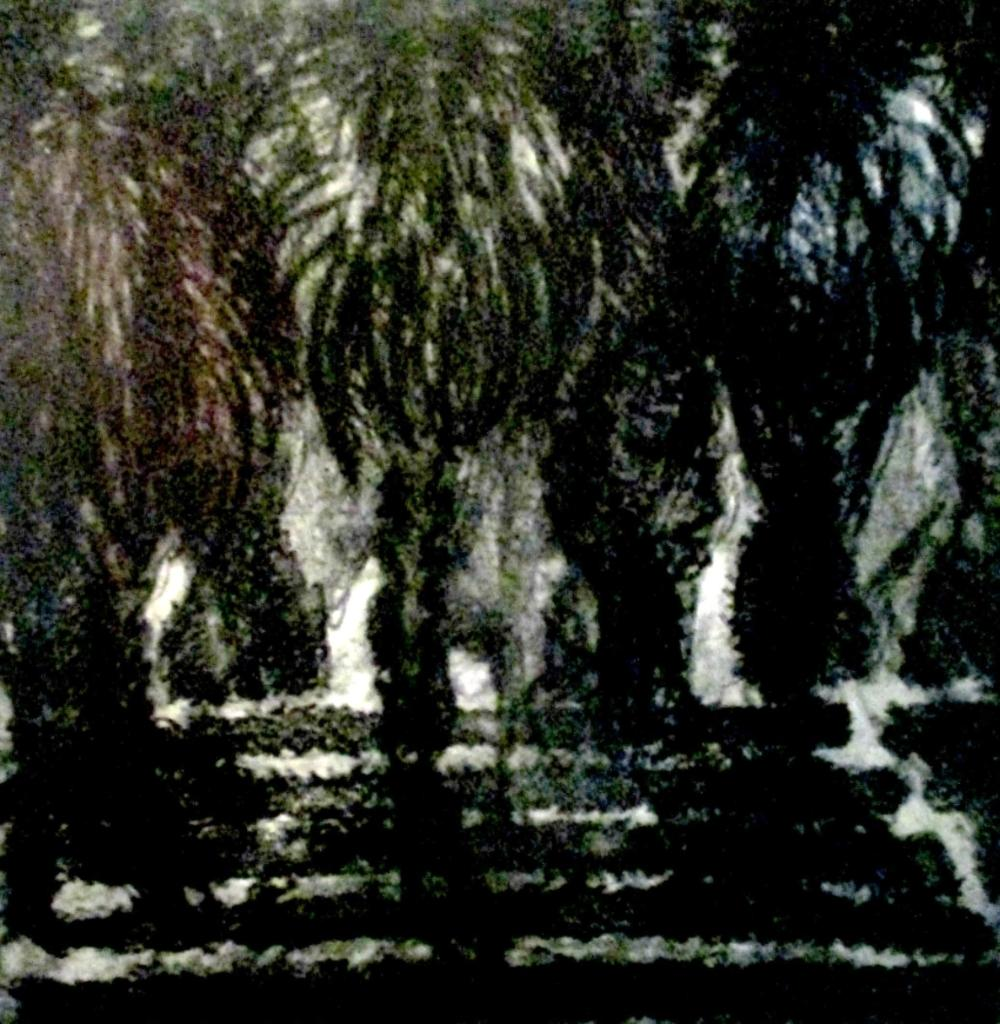What type of vegetation can be seen in the image? There are trees in the image. Can you describe the trees in the image? The provided facts do not give specific details about the trees, so we cannot describe them further. What is the setting of the image? The image features trees, which suggests a natural or outdoor setting. What grade does the friction between the trees receive in the image? There is no grading system or evaluation of friction present in the image, as it only features trees. 